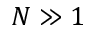<formula> <loc_0><loc_0><loc_500><loc_500>N \gg 1</formula> 